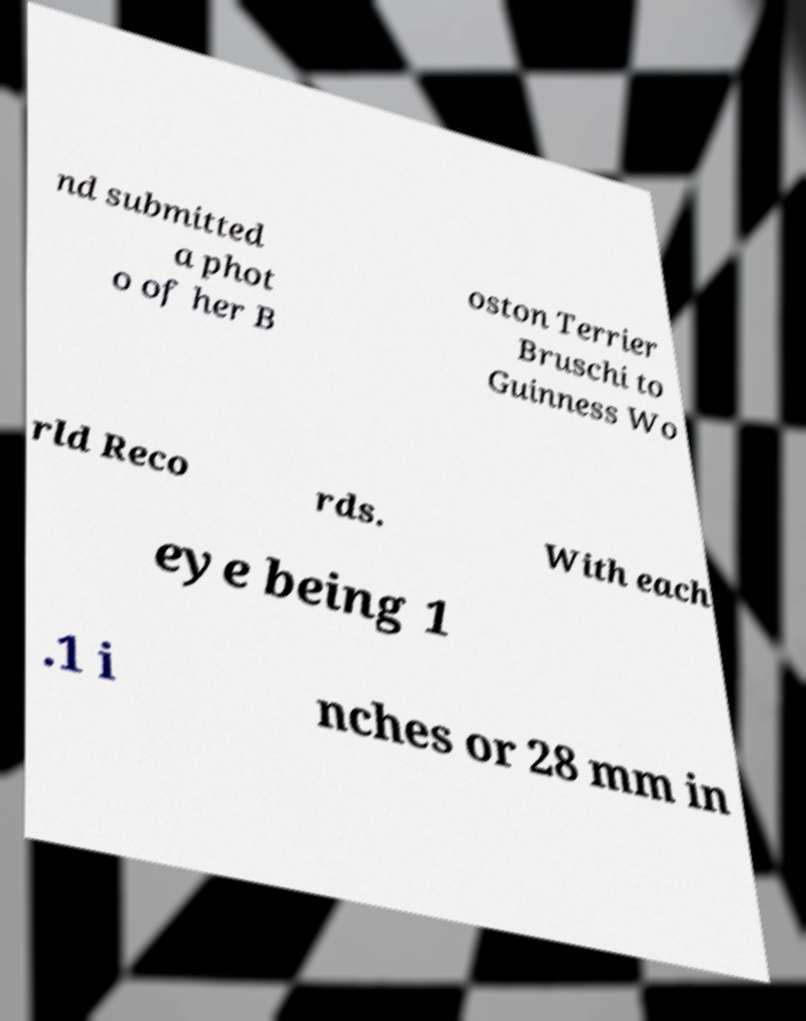There's text embedded in this image that I need extracted. Can you transcribe it verbatim? nd submitted a phot o of her B oston Terrier Bruschi to Guinness Wo rld Reco rds. With each eye being 1 .1 i nches or 28 mm in 